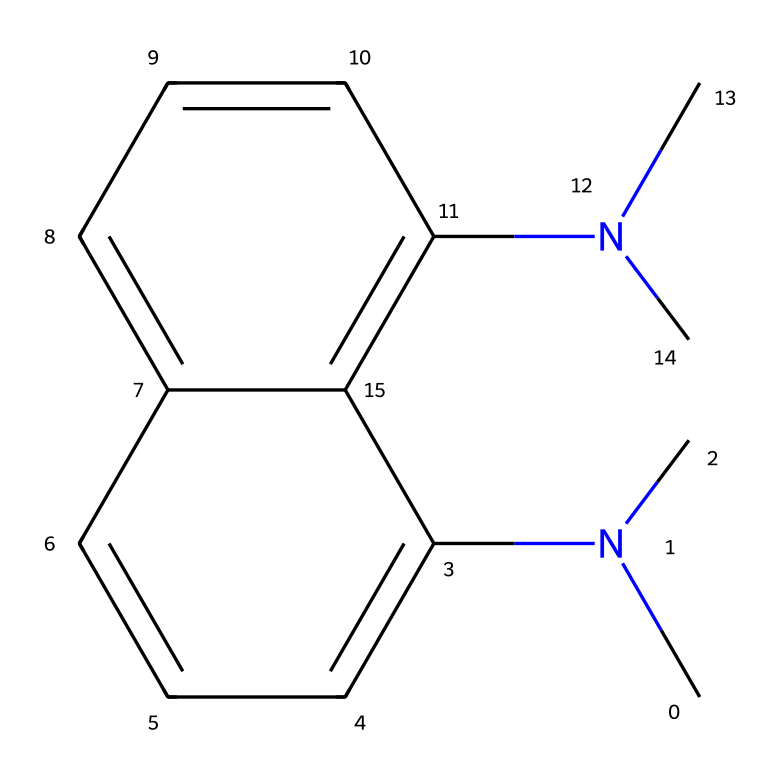What is the total number of nitrogen atoms in this structure? The SMILES representation shows 'N' two times, indicating the presence of two nitrogen atoms in the structure.
Answer: 2 How many rings are present in the chemical structure? The structure features interconnected aromatic systems, visually indicated, and after analysis, there are two distinct ring systems formed by the carbon atoms.
Answer: 2 What functional group is primarily represented in this chemical? The presence of nitrogen atom within the structure denotes that this chemical structure is based on a proton sponge, known for amine functional groups.
Answer: amine How many carbon atoms are present in the chemical structure? By counting the carbon (C) symbols in the SMILES notation, there are a total of 16 carbon atoms present in the entire structure.
Answer: 16 What type of hybridization do the nitrogen atoms in this structure predominantly exhibit? The nitrogen atoms in this chemical structure are sp3 hybridized due to the presence of lone pairs and being bonded to the carbon atoms, which affects their bonding capabilities.
Answer: sp3 What is the role of this chemical as a superbase? This compound exhibits high basicity due to the presence of the nitrogen atoms, which are capable of significantly accepting protons, characteristic of superbases.
Answer: basicity 